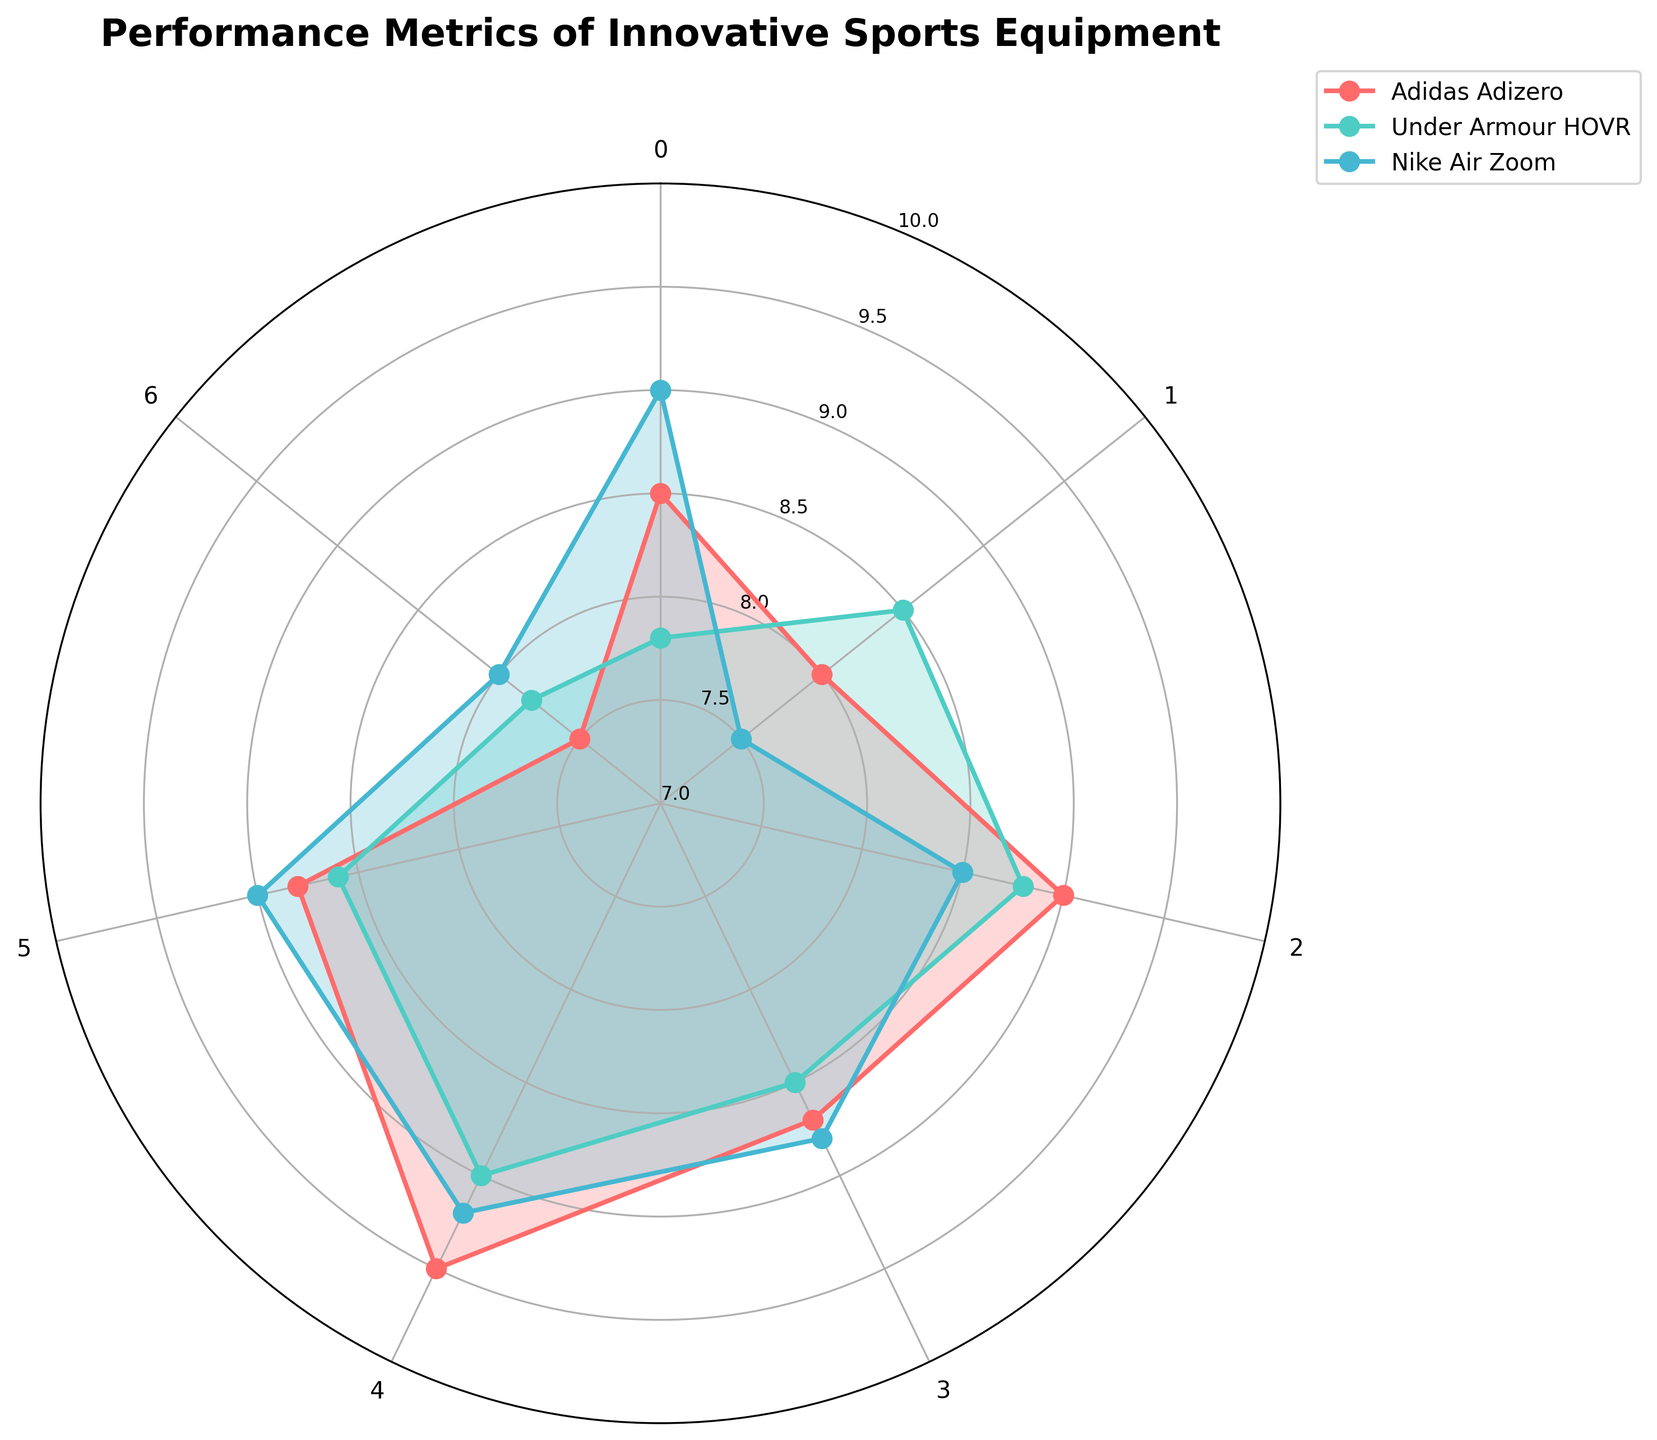What is the title of the radar chart? The title of the chart is prominently displayed at the top of the figure, indicating the main subject being presented.
Answer: Performance Metrics of Innovative Sports Equipment Which brand scored the highest in "Speed Enhancement"? By examining the "Speed Enhancement" metric on the radar chart, we can see which brand reaches the highest value on the corresponding axis.
Answer: Nike Air Zoom In which category does Adidas Adizero score the highest? By looking at the data points for Adidas Adizero across all categories, we identify the highest value point.
Answer: Weight Compare the comfort levels of all listed brands. Which brand stands out? Review the comfort scores for all brands and identify any significant differences. Adidas Adizero leads at 9.0, followed closely by Asics Metarun at 8.9, then Nike Air Zoom at 8.5, and finally Under Armour HOVR at 8.8.
Answer: Adidas Adizero What is the average score of Under Armour HOVR across all categories? Sum the scores for Under Armour HOVR in each category and divide by the number of categories. Sum is 59.0 over 7 categories: (7.8 + 8.5 + 8.8 + 8.5 + 9.0 + 8.6 + 7.8)/7.
Answer: 8.43 Does Asics Metarun score higher in "Flexibility" or "Durability"? Compare the values for Asics Metarun in both "Flexibility" and "Durability" categories to see which is greater.
Answer: Durability Which metric has the smallest difference between the highest and lowest scores across all brands? Assess each metric, 
calculate the range (highest minus lowest score) for all brands, identify the smallest range. For Breathability: highest 9.0, lowest 8.6, difference of 0.4. Others are larger.
Answer: Breathability How does the "Price" metric compare between Nike Air Zoom and Asics Metarun? Compare the values for "Price" in the radar chart for two specific brands. Nike Air Zoom has a value of 8.0, while Asics Metarun scores 7.9.
Answer: Nike Air Zoom scores higher Which brand shows the most balanced performance across all metrics? Examine each brand's performance across all metrics to determine which has the least variation in scores. Under Armour HOVR shows relatively balanced scores without extreme highs or lows.
Answer: Under Armour HOVR 